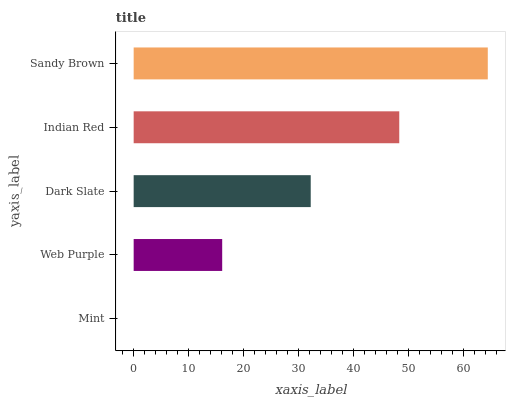Is Mint the minimum?
Answer yes or no. Yes. Is Sandy Brown the maximum?
Answer yes or no. Yes. Is Web Purple the minimum?
Answer yes or no. No. Is Web Purple the maximum?
Answer yes or no. No. Is Web Purple greater than Mint?
Answer yes or no. Yes. Is Mint less than Web Purple?
Answer yes or no. Yes. Is Mint greater than Web Purple?
Answer yes or no. No. Is Web Purple less than Mint?
Answer yes or no. No. Is Dark Slate the high median?
Answer yes or no. Yes. Is Dark Slate the low median?
Answer yes or no. Yes. Is Mint the high median?
Answer yes or no. No. Is Mint the low median?
Answer yes or no. No. 